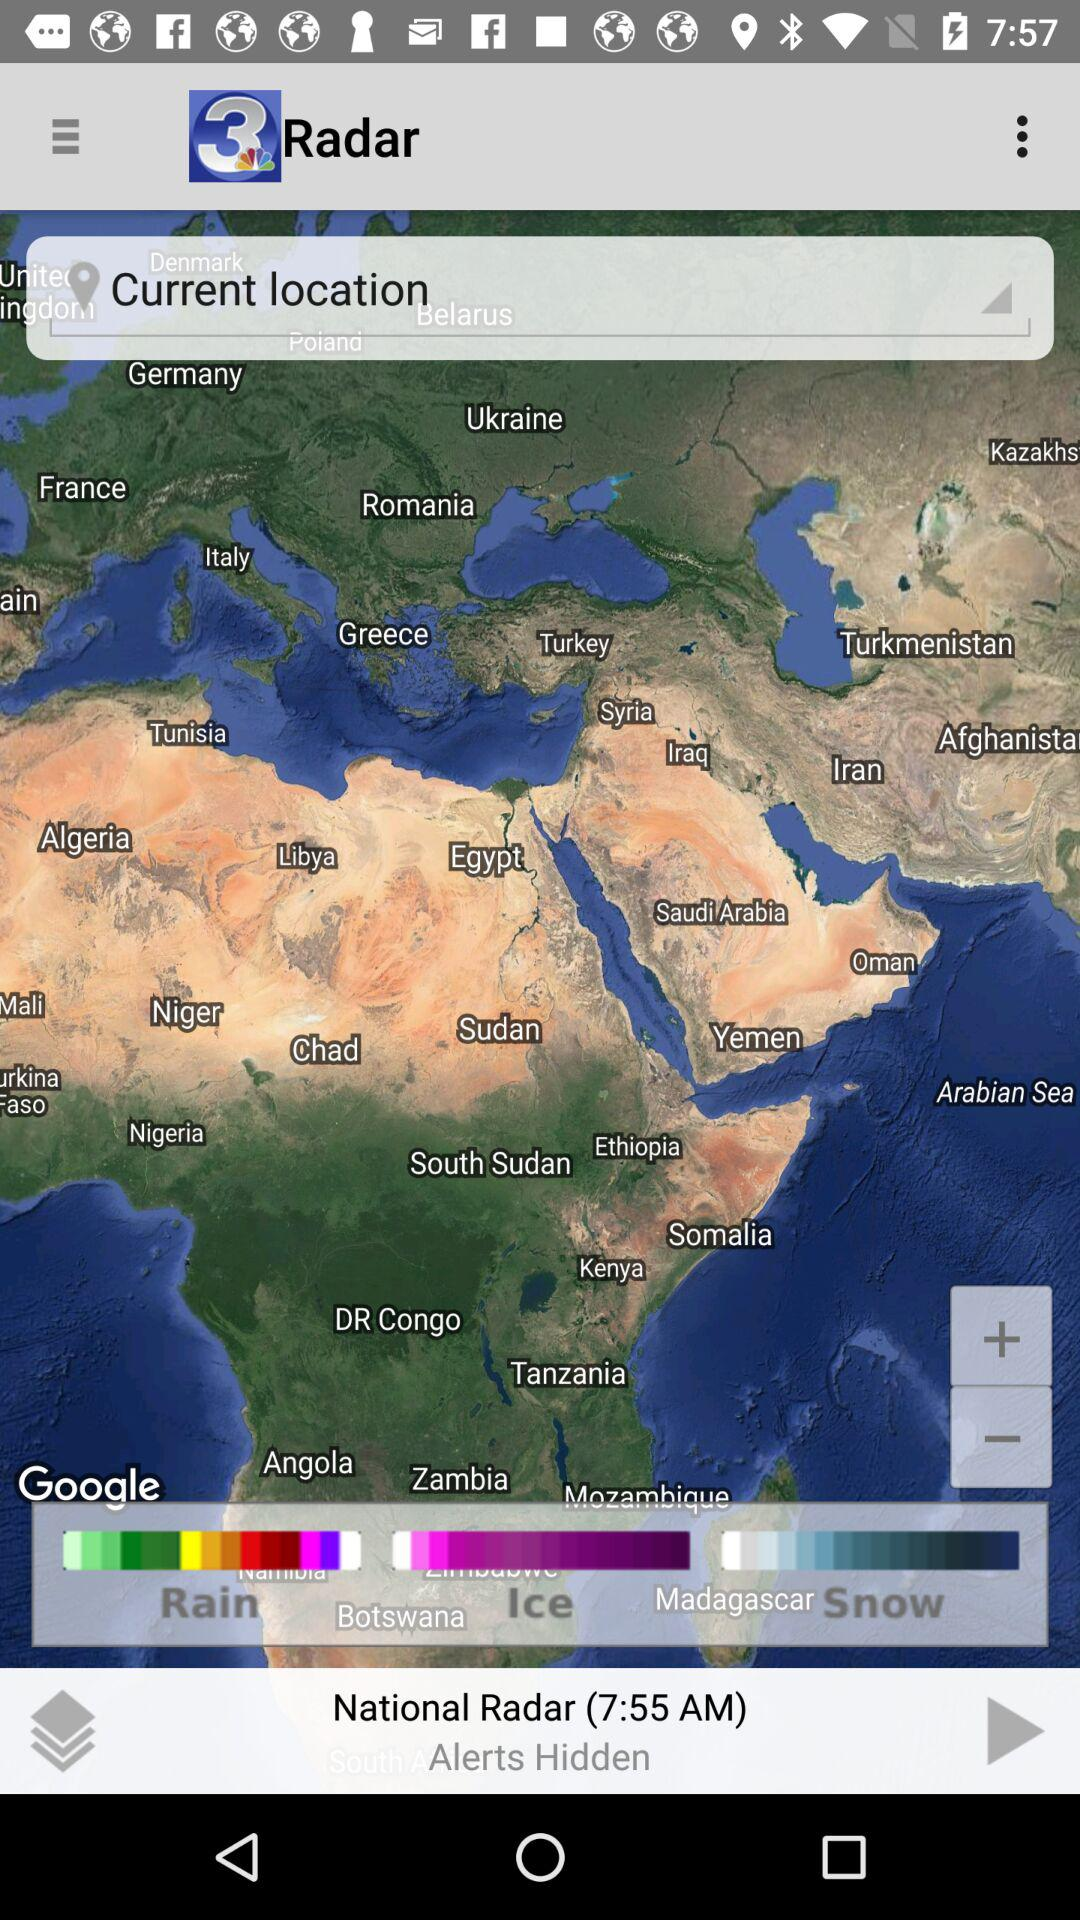What is the given time? The given time is 7:55 AM. 